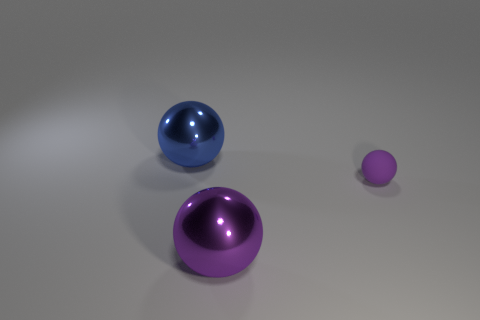Add 2 small purple matte balls. How many objects exist? 5 Subtract all purple rubber objects. Subtract all small purple matte objects. How many objects are left? 1 Add 1 matte spheres. How many matte spheres are left? 2 Add 1 cyan shiny cylinders. How many cyan shiny cylinders exist? 1 Subtract 0 purple cylinders. How many objects are left? 3 